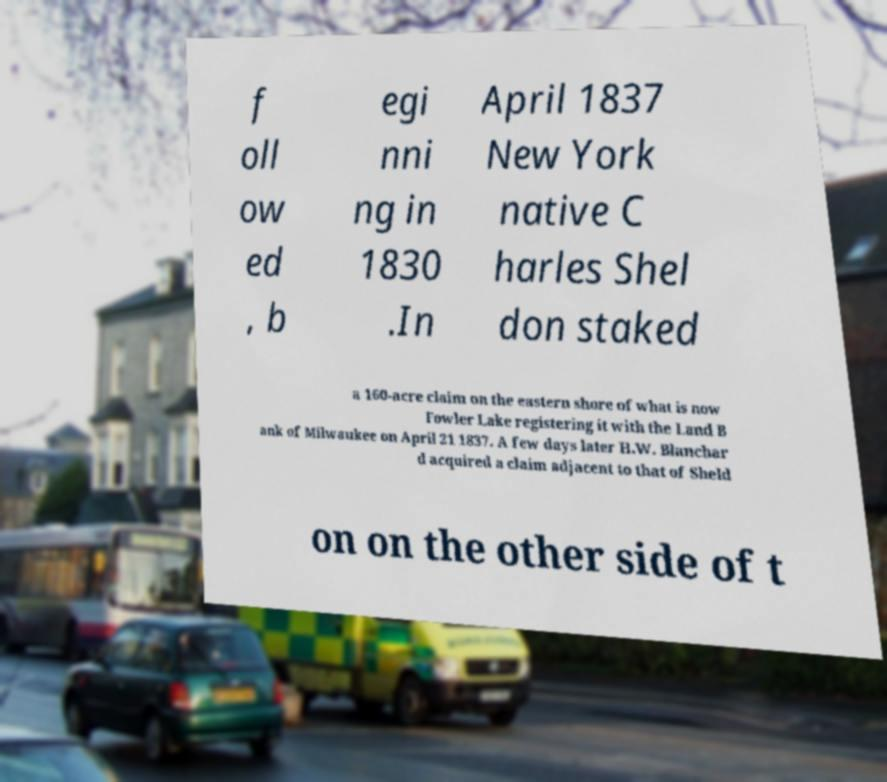Could you assist in decoding the text presented in this image and type it out clearly? f oll ow ed , b egi nni ng in 1830 .In April 1837 New York native C harles Shel don staked a 160-acre claim on the eastern shore of what is now Fowler Lake registering it with the Land B ank of Milwaukee on April 21 1837. A few days later H.W. Blanchar d acquired a claim adjacent to that of Sheld on on the other side of t 